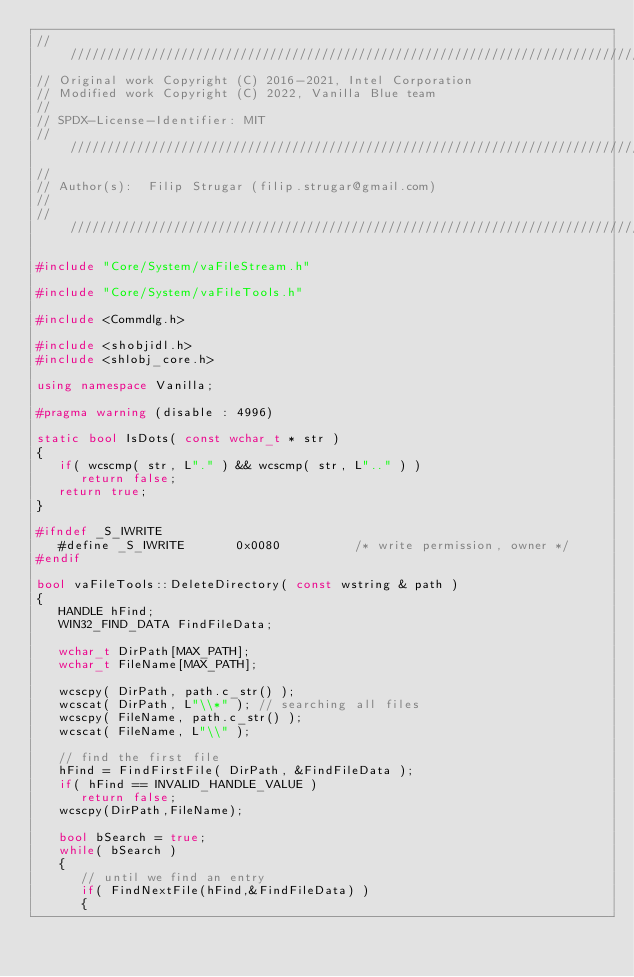Convert code to text. <code><loc_0><loc_0><loc_500><loc_500><_C++_>///////////////////////////////////////////////////////////////////////////////////////////////////////////////////////
// Original work Copyright (C) 2016-2021, Intel Corporation  
// Modified work Copyright (C) 2022, Vanilla Blue team 
// 
// SPDX-License-Identifier: MIT
///////////////////////////////////////////////////////////////////////////////////////////////////////////////////////
//
// Author(s):  Filip Strugar (filip.strugar@gmail.com)
//
///////////////////////////////////////////////////////////////////////////////////////////////////////////////////////

#include "Core/System/vaFileStream.h"

#include "Core/System/vaFileTools.h"

#include <Commdlg.h>

#include <shobjidl.h> 
#include <shlobj_core.h>

using namespace Vanilla;

#pragma warning (disable : 4996)

static bool IsDots( const wchar_t * str )
{
   if( wcscmp( str, L"." ) && wcscmp( str, L".." ) ) 
      return false;
   return true;
}

#ifndef _S_IWRITE
   #define _S_IWRITE       0x0080          /* write permission, owner */
#endif

bool vaFileTools::DeleteDirectory( const wstring & path )
{
   HANDLE hFind;
   WIN32_FIND_DATA FindFileData;

   wchar_t DirPath[MAX_PATH];
   wchar_t FileName[MAX_PATH];

   wcscpy( DirPath, path.c_str() );
   wcscat( DirPath, L"\\*" ); // searching all files
   wcscpy( FileName, path.c_str() );
   wcscat( FileName, L"\\" );

   // find the first file
   hFind = FindFirstFile( DirPath, &FindFileData );
   if( hFind == INVALID_HANDLE_VALUE )
      return false;
   wcscpy(DirPath,FileName);

   bool bSearch = true;
   while( bSearch ) 
   {
      // until we find an entry
      if( FindNextFile(hFind,&FindFileData) )
      {</code> 